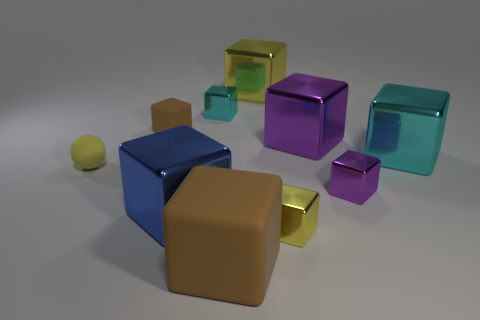What color is the sphere?
Offer a very short reply. Yellow. Is there anything else of the same color as the matte sphere?
Offer a terse response. Yes. Are the yellow thing in front of the small yellow rubber ball and the cyan thing on the right side of the large yellow metallic object made of the same material?
Ensure brevity in your answer.  Yes. What material is the big cube that is both in front of the large purple metallic object and to the right of the small yellow shiny object?
Your answer should be compact. Metal. Do the large blue metal thing and the cyan metal object on the left side of the large rubber object have the same shape?
Keep it short and to the point. Yes. There is a yellow block behind the yellow metal thing in front of the brown thing that is to the left of the large blue metallic block; what is its material?
Give a very brief answer. Metal. What number of other objects are there of the same size as the blue block?
Provide a short and direct response. 4. Does the tiny ball have the same color as the small rubber block?
Offer a very short reply. No. What number of objects are right of the yellow metal block that is left of the yellow shiny cube in front of the small brown rubber block?
Your answer should be very brief. 4. What material is the purple object behind the cyan shiny object on the right side of the tiny cyan shiny block?
Offer a terse response. Metal. 